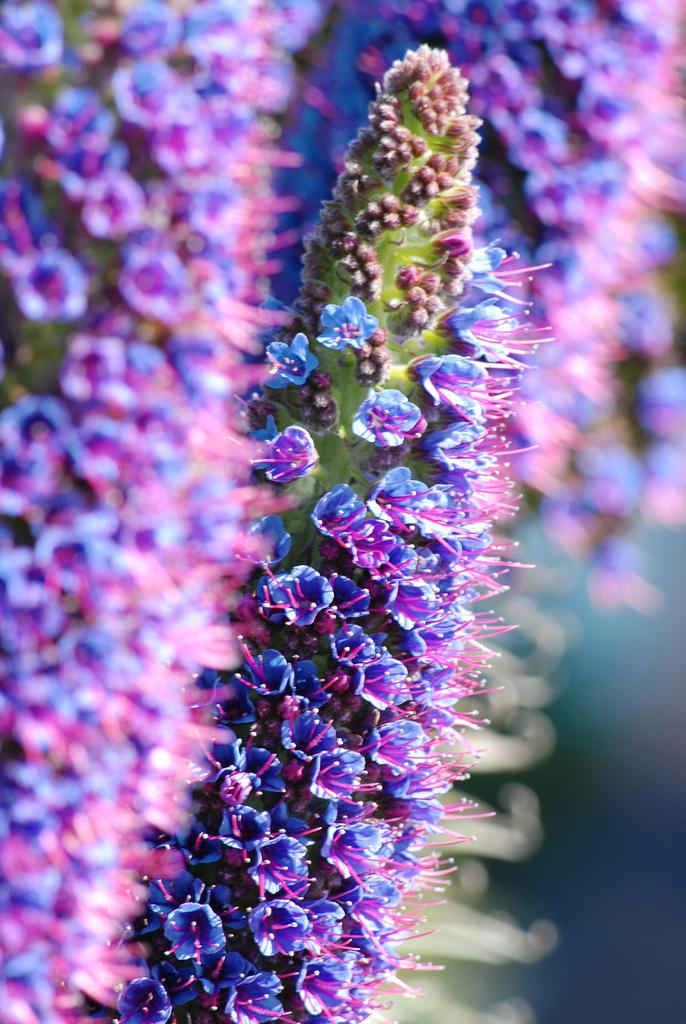What is the main subject of the image? The main subject of the image is a bunch of flowers. Can you describe the flowers' location in the image? The flowers are near plants in the image. What type of game is being played in the image? There is no game being played in the image; it features a bunch of flowers near plants. What type of harmony can be observed between the flowers and the plants in the image? The image does not depict any interaction between the flowers and the plants, so it is not possible to determine if there is any harmony between them. 